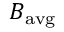Convert formula to latex. <formula><loc_0><loc_0><loc_500><loc_500>B _ { a v g }</formula> 